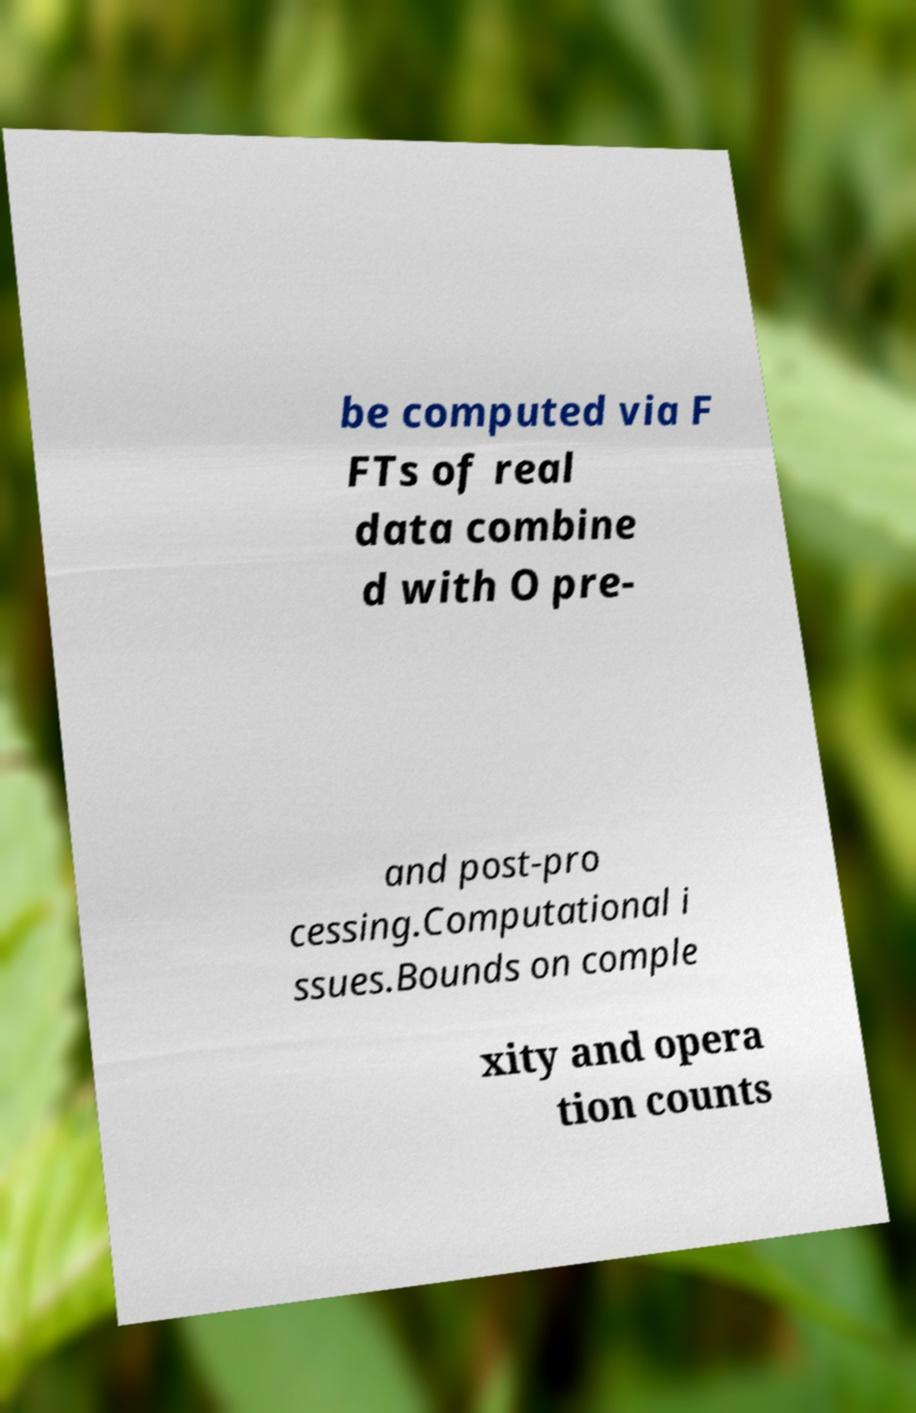Could you extract and type out the text from this image? be computed via F FTs of real data combine d with O pre- and post-pro cessing.Computational i ssues.Bounds on comple xity and opera tion counts 